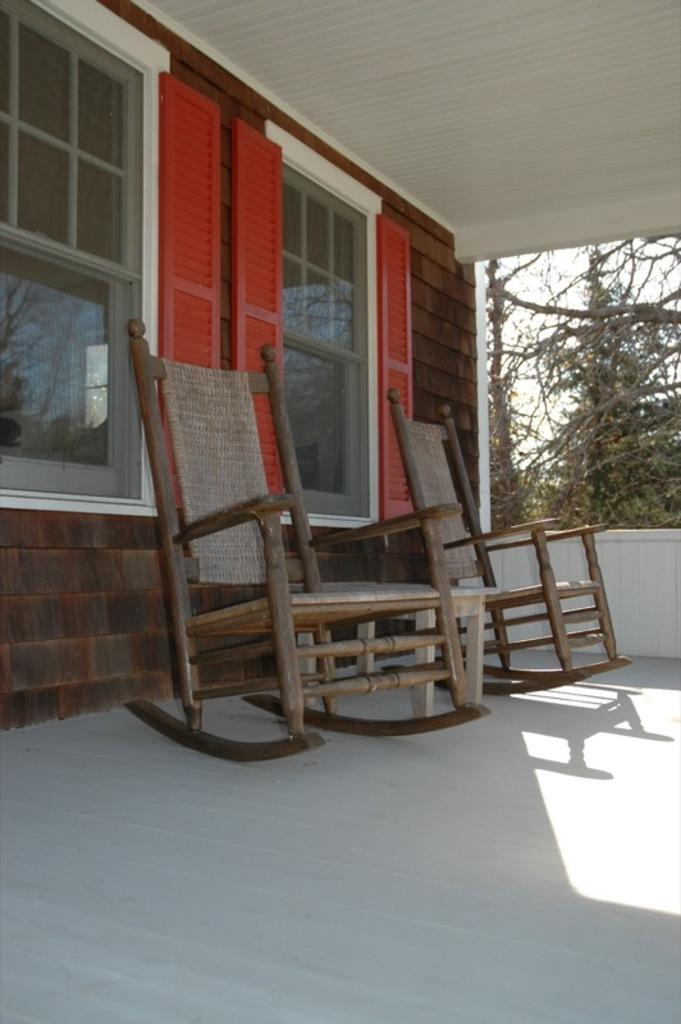What objects are located in the center of the image? There are two chairs in the center of the image. How are the chairs positioned in relation to the ground? The chairs are placed on the ground. What can be seen in the background of the image? There is a building with windows and a group of trees in the background. What part of the natural environment is visible in the image? The sky is visible in the background. What type of joke is being told by the porter in the image? There is no porter or joke present in the image; it features two chairs placed on the ground with a background of a building, trees, and the sky. 